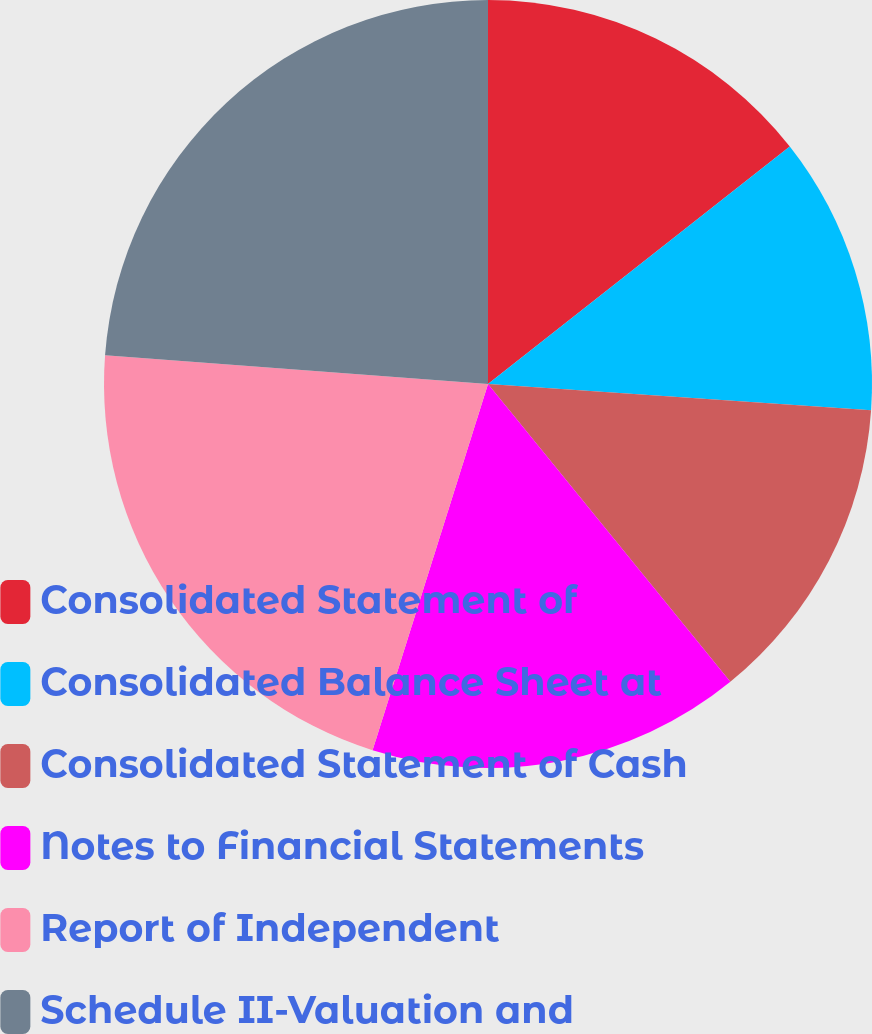Convert chart to OTSL. <chart><loc_0><loc_0><loc_500><loc_500><pie_chart><fcel>Consolidated Statement of<fcel>Consolidated Balance Sheet at<fcel>Consolidated Statement of Cash<fcel>Notes to Financial Statements<fcel>Report of Independent<fcel>Schedule II-Valuation and<nl><fcel>14.39%<fcel>11.7%<fcel>13.04%<fcel>15.73%<fcel>21.33%<fcel>23.81%<nl></chart> 